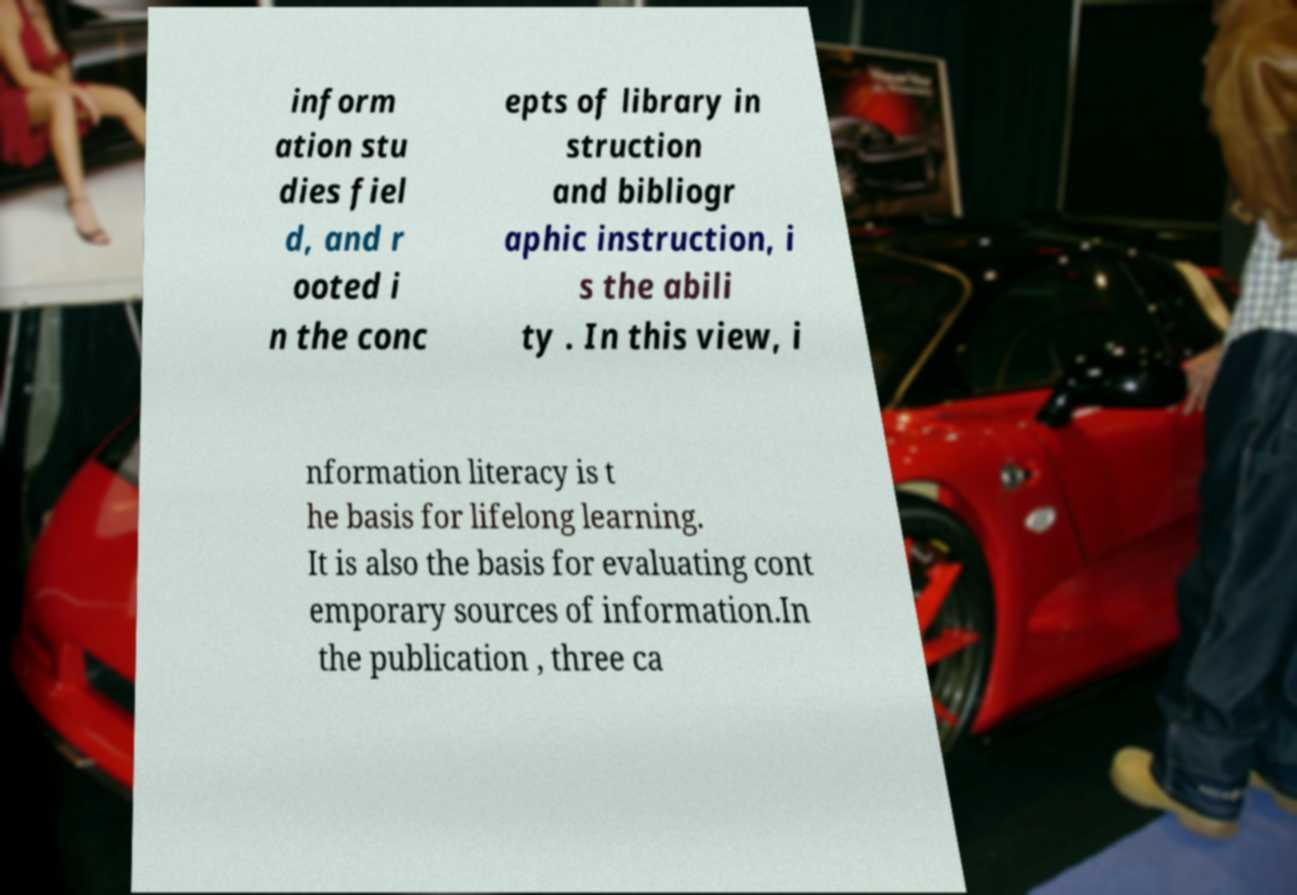For documentation purposes, I need the text within this image transcribed. Could you provide that? inform ation stu dies fiel d, and r ooted i n the conc epts of library in struction and bibliogr aphic instruction, i s the abili ty . In this view, i nformation literacy is t he basis for lifelong learning. It is also the basis for evaluating cont emporary sources of information.In the publication , three ca 